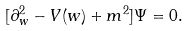<formula> <loc_0><loc_0><loc_500><loc_500>[ \partial _ { w } ^ { 2 } - V ( w ) + m ^ { 2 } ] \Psi = 0 .</formula> 